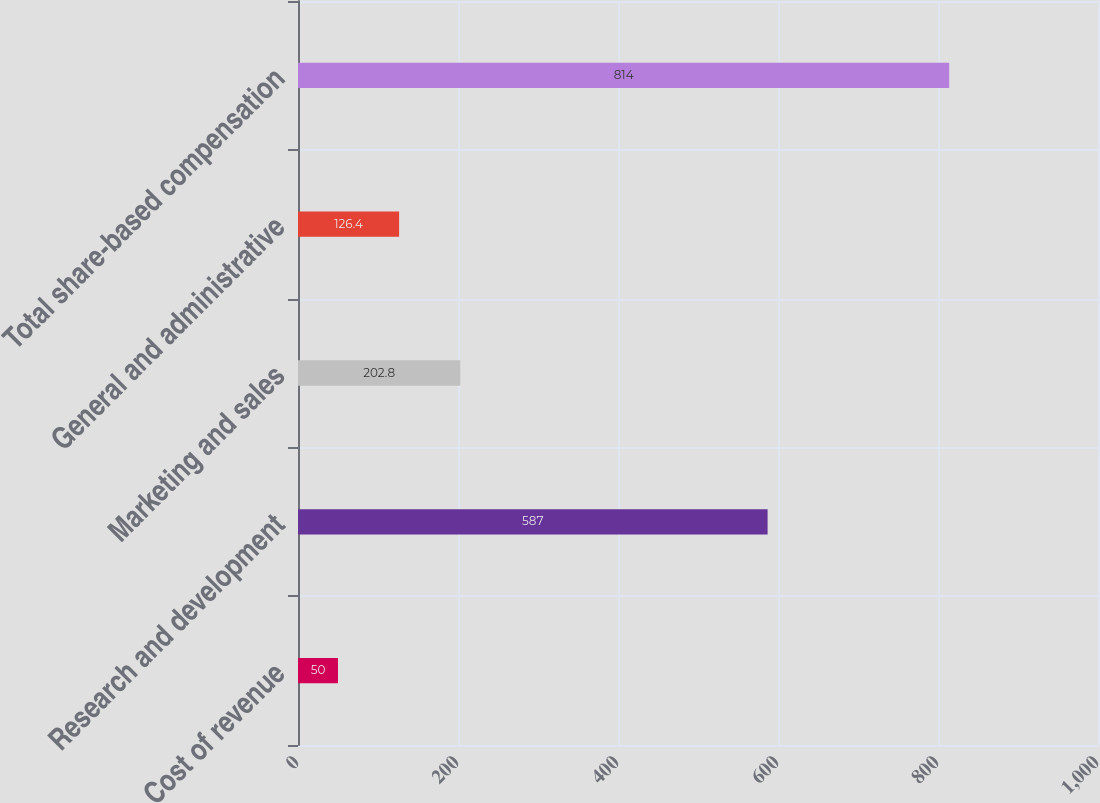Convert chart to OTSL. <chart><loc_0><loc_0><loc_500><loc_500><bar_chart><fcel>Cost of revenue<fcel>Research and development<fcel>Marketing and sales<fcel>General and administrative<fcel>Total share-based compensation<nl><fcel>50<fcel>587<fcel>202.8<fcel>126.4<fcel>814<nl></chart> 